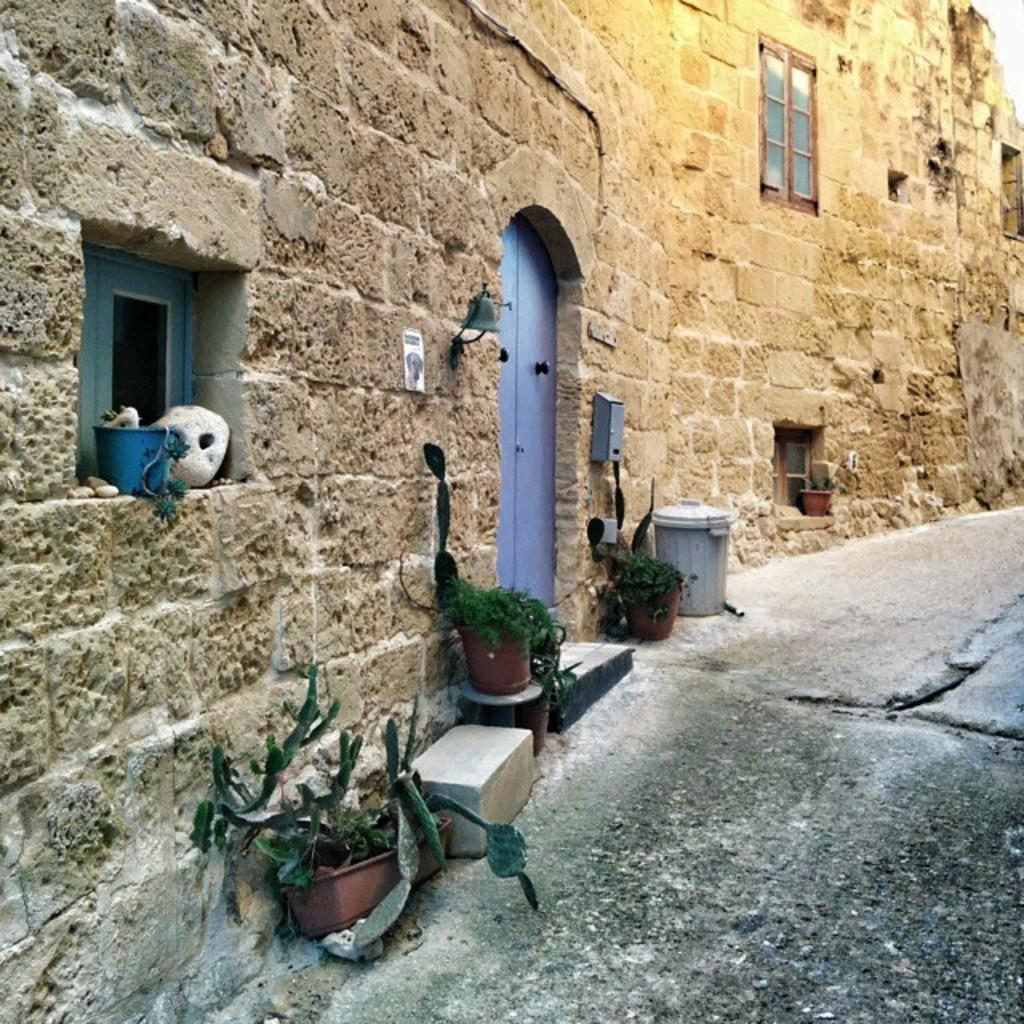What type of structure is visible in the image? There is a building in the image. What is one of the main features of the building? There is a door in the image. Are there any openings in the building? Yes, there are windows in the image. What type of greenery can be seen in the image? House plants are present in the image. What is used for waste disposal in the image? There is a dustbin in the image. Is there any blood visible on the house plants in the image? No, there is no blood visible on the house plants in the image. What type of pets can be seen playing with the dustbin in the image? There are no pets present in the image. 